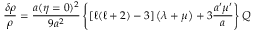Convert formula to latex. <formula><loc_0><loc_0><loc_500><loc_500>\frac { \delta \rho } { \rho } = \frac { a ( \eta = 0 ) ^ { 2 } } { 9 a ^ { 2 } } \left \{ \left [ \ell ( \ell + 2 ) - 3 \right ] \left ( \lambda + \mu \right ) + 3 \frac { a ^ { \prime } \mu ^ { \prime } } { a } \right \} Q</formula> 